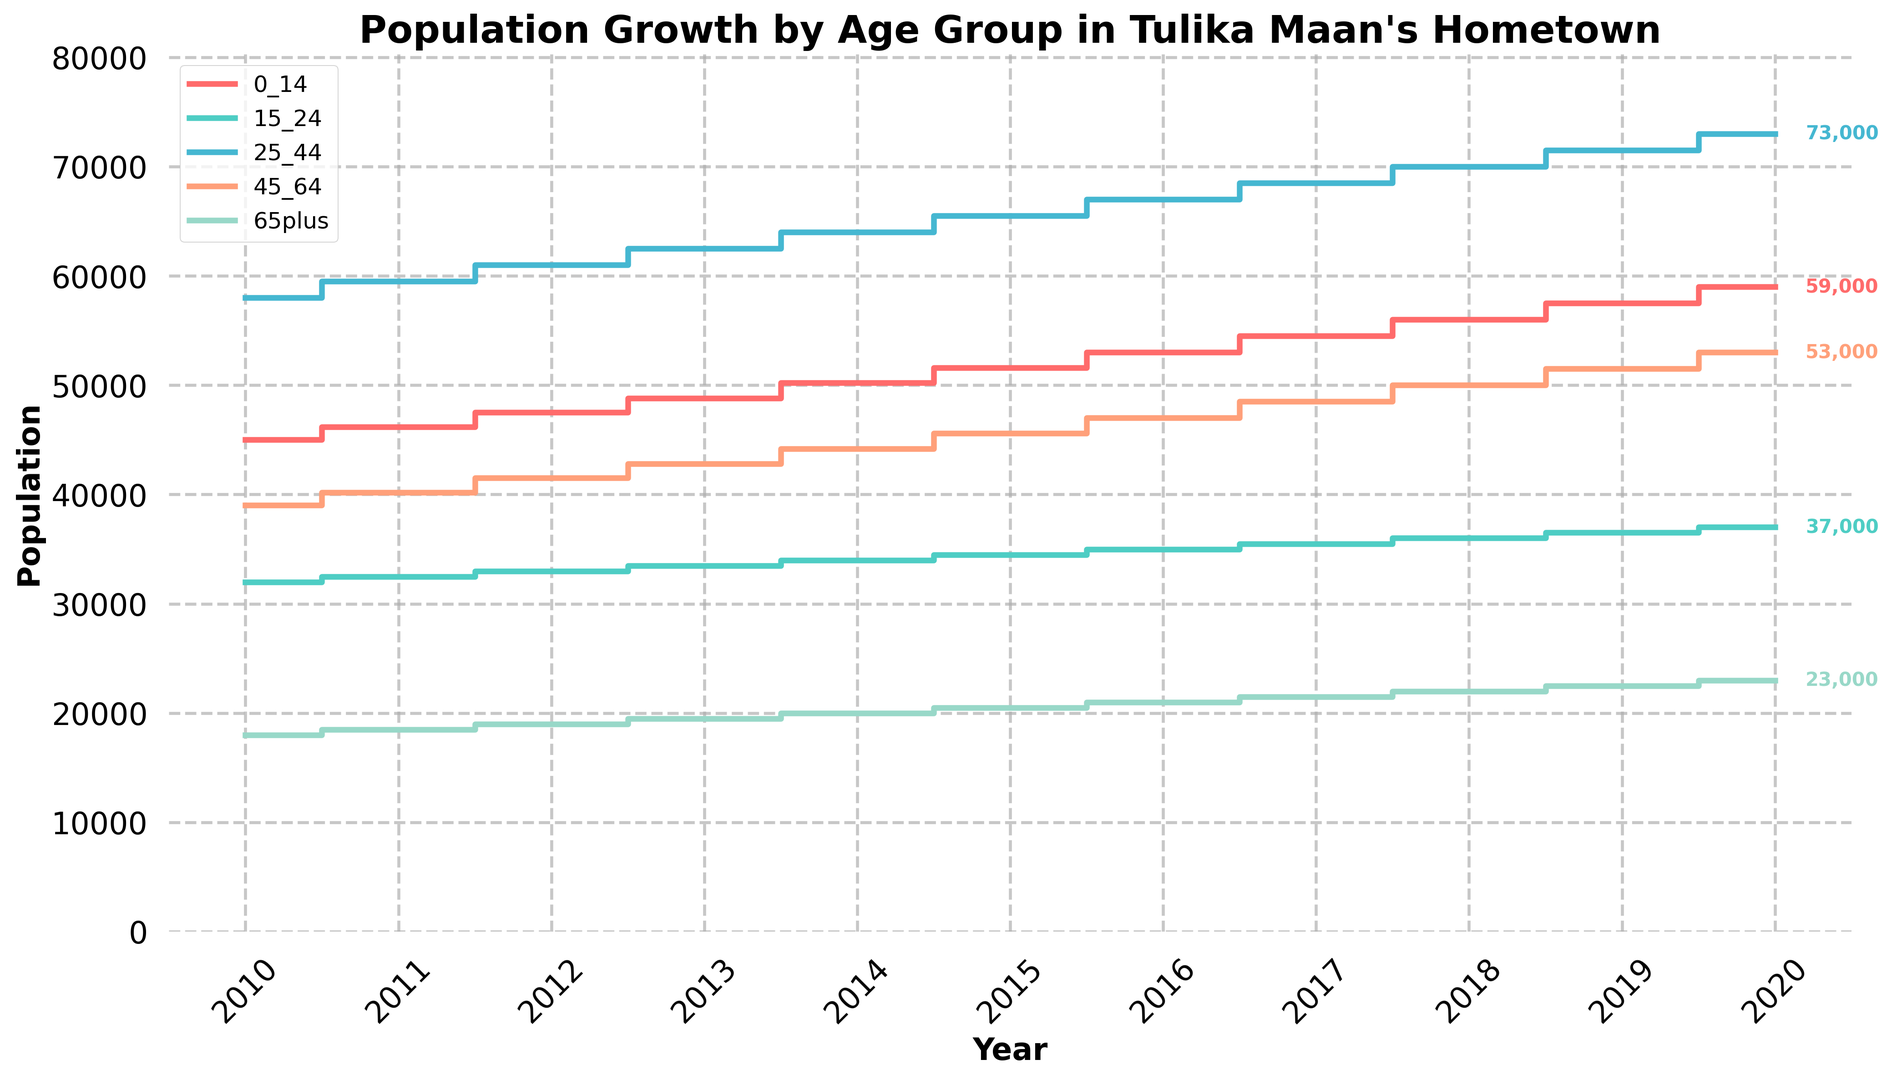What's the population of individuals aged 0-14 in 2010? Look at the value on the vertical axis corresponding to the year 2010 for the 0-14 age group line (red). It reads 45,000.
Answer: 45,000 How did the population of those aged 65 and above in 2020 compare to 2010? Compare the 65+ age group (green line) values between 2010 and 2020. In 2010, it was 18,000 and in 2020, it was 23,000. The population increased by 5,000.
Answer: Increased by 5,000 Which age group had the highest population in 2019? Look at the height of the lines in 2019 and compare their values. The 25-44 age group had the highest value, around 71,500.
Answer: 25-44 What is the difference in the 15-24 age group population between 2012 and 2016? Subtract the 2012 value from the 2016 value for the 15-24 age group. The values are 33,000 in 2012 and 35,000 in 2016. The difference is 35,000 - 33,000 = 2,000.
Answer: 2,000 What was the overall trend in the population of the 45-64 age group from 2010 to 2020? Observe the line representing the 45-64 age group. It shows a consistent upward trend from 2010 (39,000) to 2020 (53,000).
Answer: Increasing trend Which year had the smallest population for the 0-14 age group, and what was the value? Identify the lowest point on the 0-14 age group line. The smallest value is in 2010 at 45,000.
Answer: 2010, 45,000 What's the sum of the populations of the 25-44 and 65+ age groups in 2020? Add the population values of the 25-44 age group (73,000) and the 65+ age group (23,000) for the year 2020. The sum is 73,000 + 23,000 = 96,000.
Answer: 96,000 